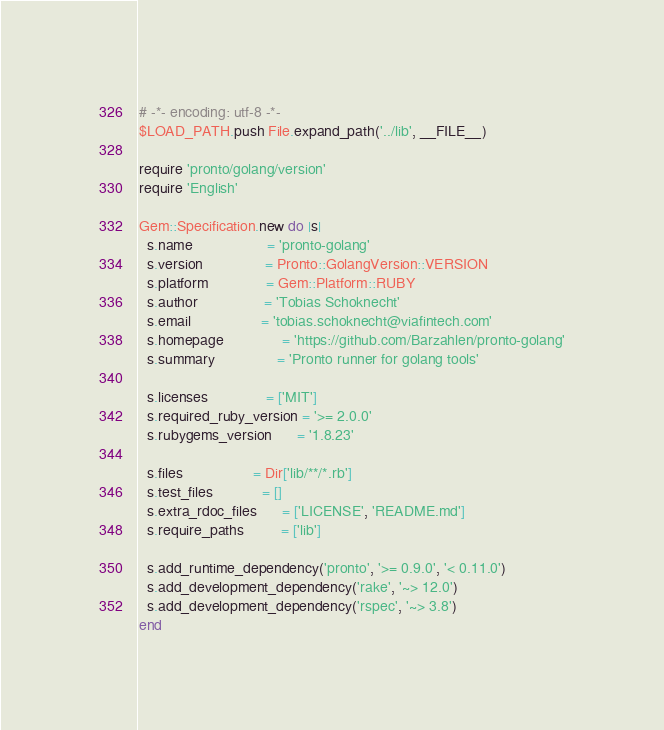<code> <loc_0><loc_0><loc_500><loc_500><_Ruby_># -*- encoding: utf-8 -*-
$LOAD_PATH.push File.expand_path('../lib', __FILE__)

require 'pronto/golang/version'
require 'English'

Gem::Specification.new do |s|
  s.name                  = 'pronto-golang'
  s.version               = Pronto::GolangVersion::VERSION
  s.platform              = Gem::Platform::RUBY
  s.author                = 'Tobias Schoknecht'
  s.email                 = 'tobias.schoknecht@viafintech.com'
  s.homepage              = 'https://github.com/Barzahlen/pronto-golang'
  s.summary               = 'Pronto runner for golang tools'

  s.licenses              = ['MIT']
  s.required_ruby_version = '>= 2.0.0'
  s.rubygems_version      = '1.8.23'

  s.files                 = Dir['lib/**/*.rb']
  s.test_files            = []
  s.extra_rdoc_files      = ['LICENSE', 'README.md']
  s.require_paths         = ['lib']

  s.add_runtime_dependency('pronto', '>= 0.9.0', '< 0.11.0')
  s.add_development_dependency('rake', '~> 12.0')
  s.add_development_dependency('rspec', '~> 3.8')
end
</code> 